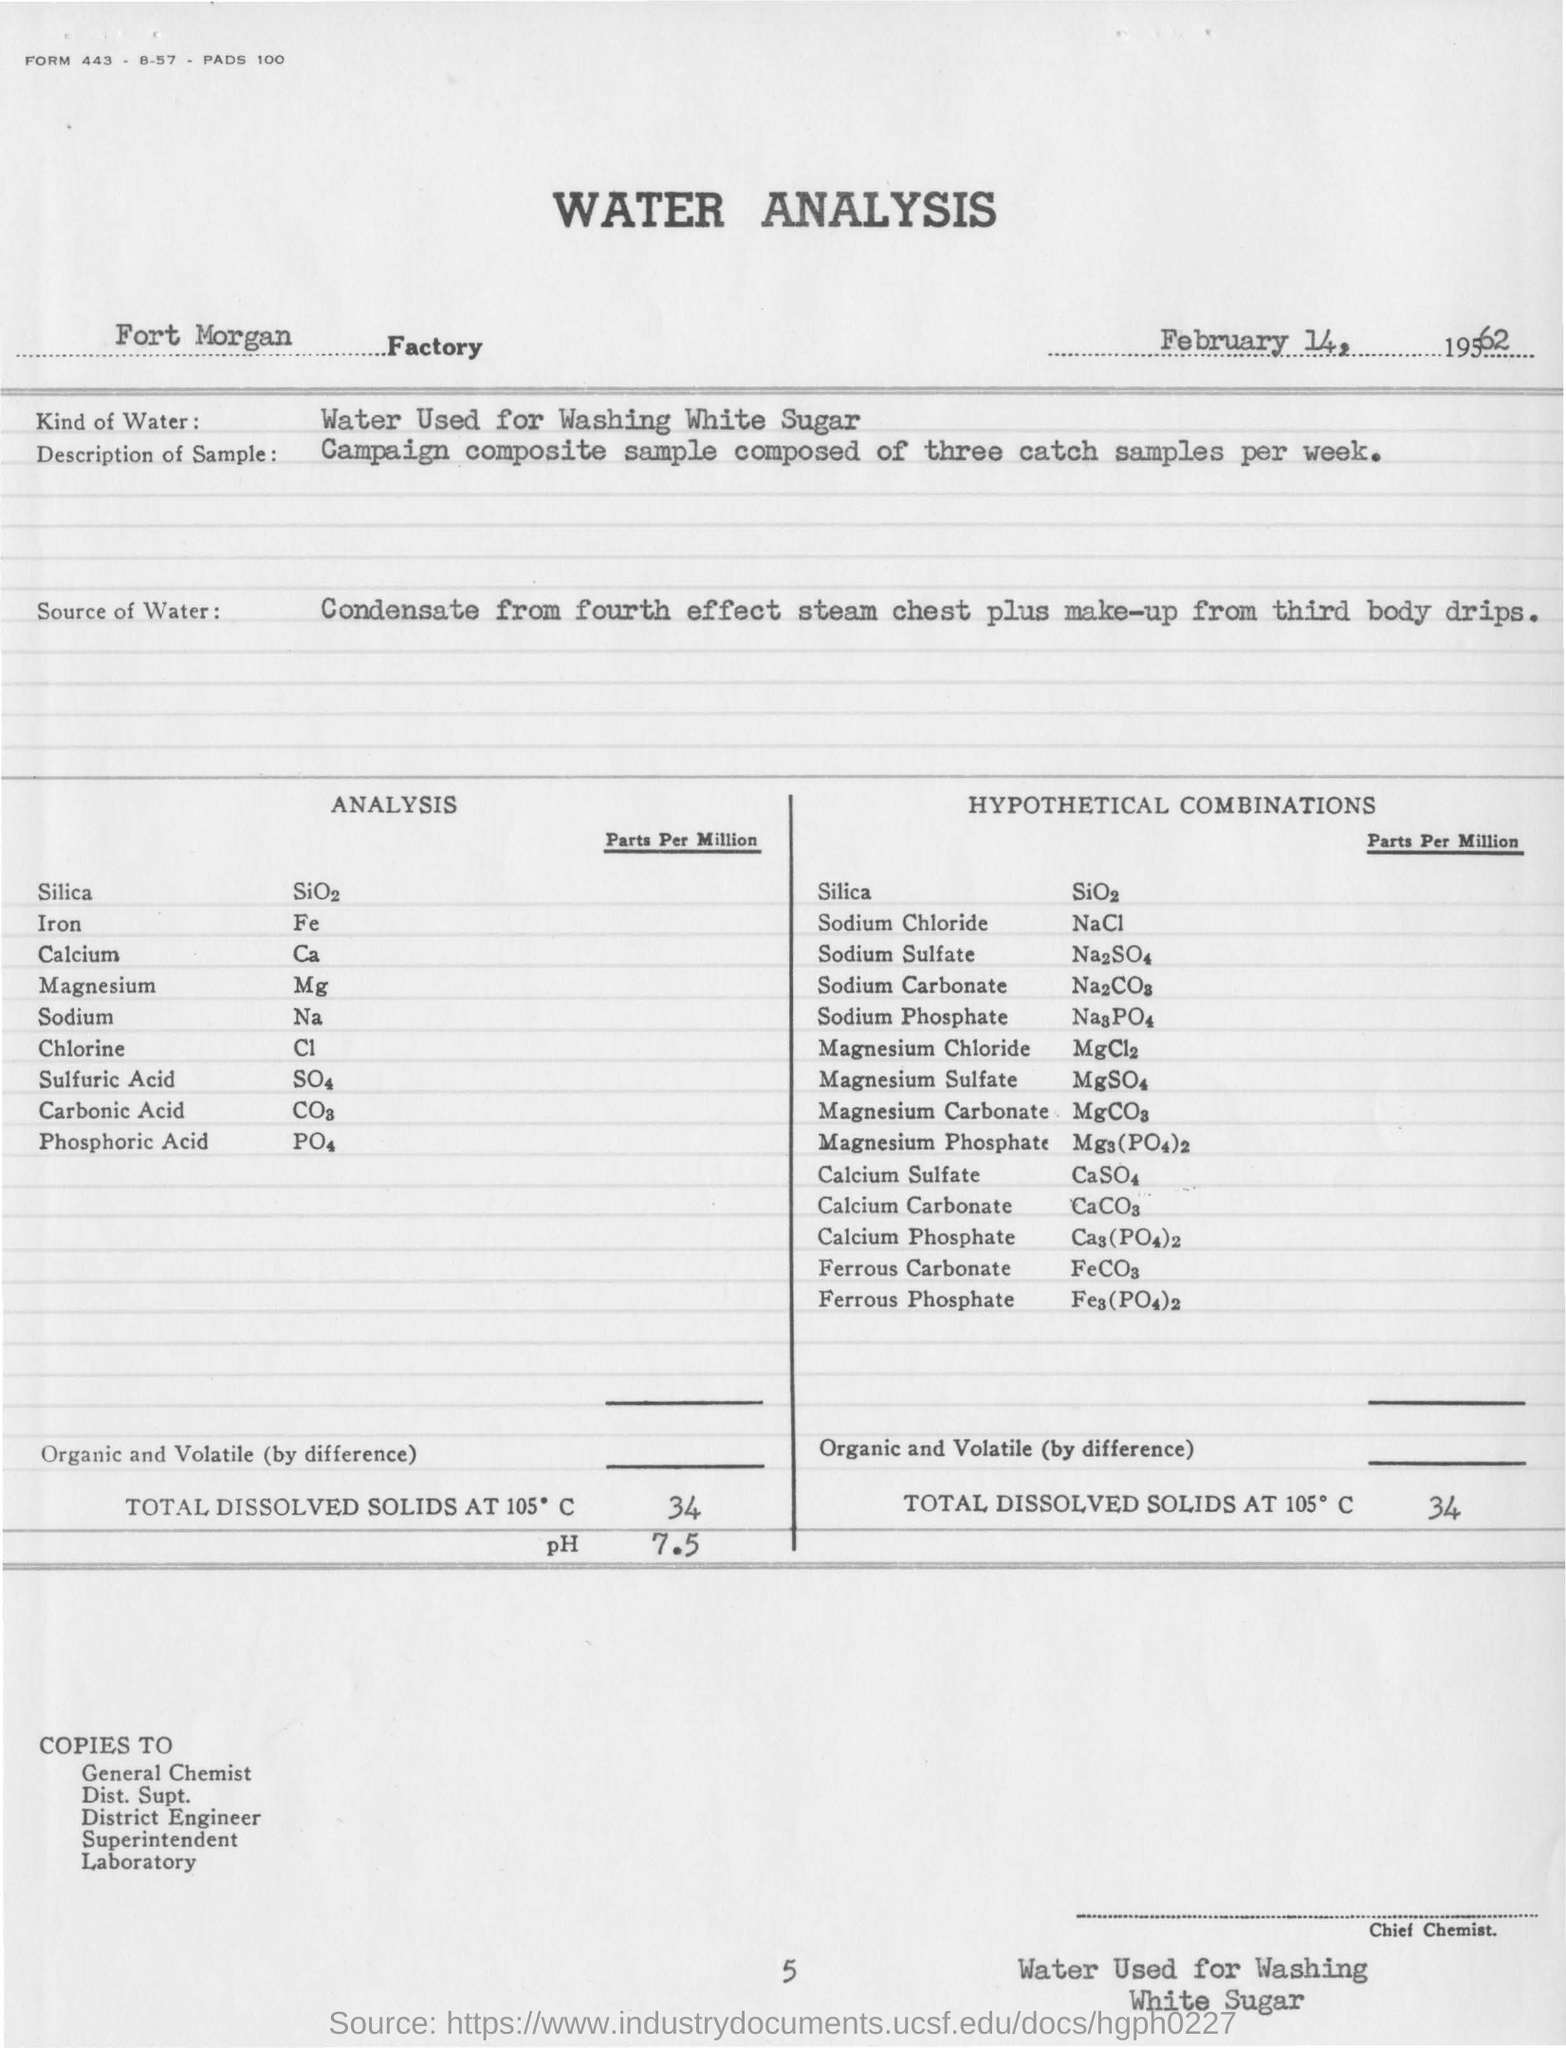Highlight a few significant elements in this photo. The water sample test was conducted on February 14, 1962, at Fort Morgan. The total dissolved solids at 105 degrees Celsius for the hypothetical combination of 34... is unknown. The water sample contains iron in the form of parts per million. Our laboratory analysis of a sample taken from Fort Morgan reveals that the pH value is 7.5. The chemical compound for Na (sodium) is known as sodium. 